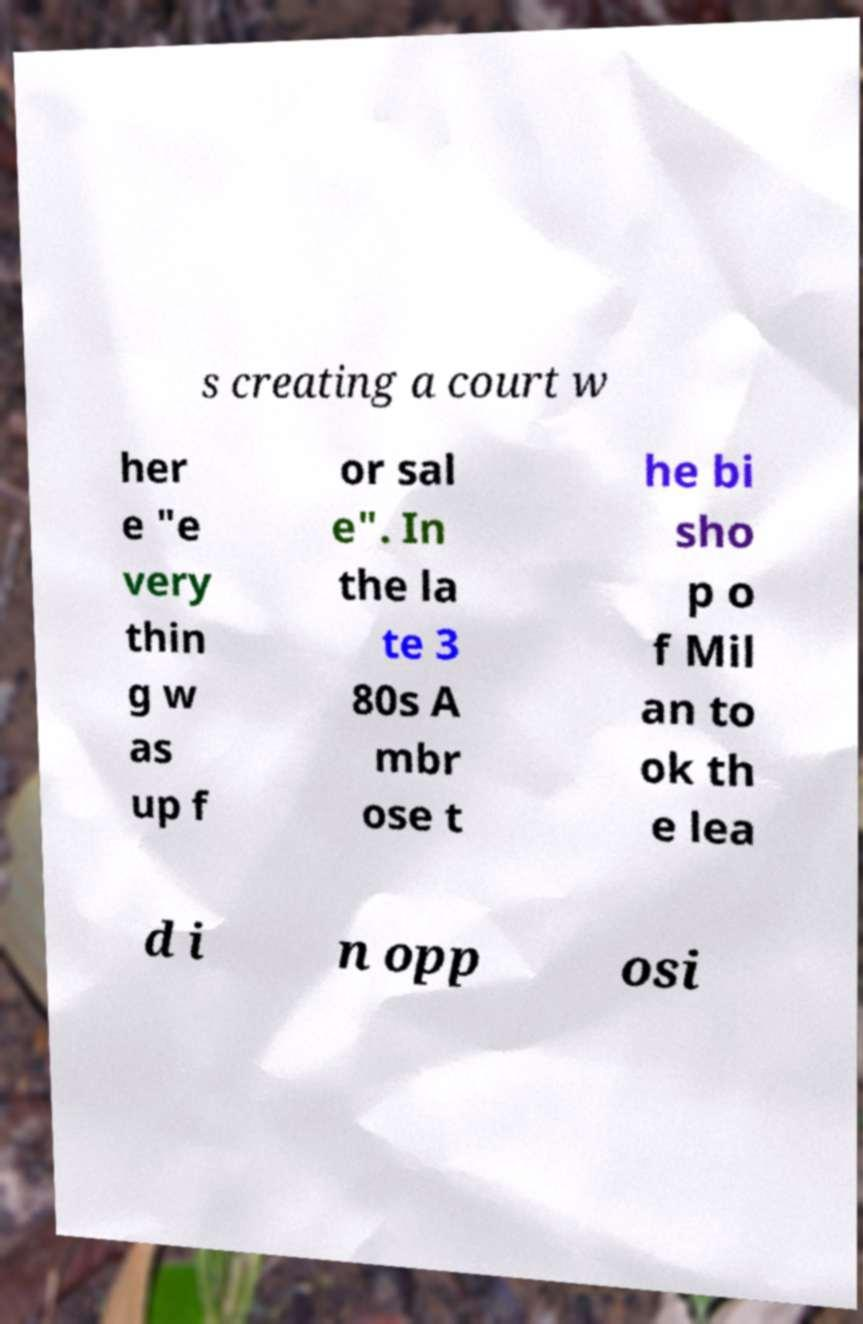Can you read and provide the text displayed in the image?This photo seems to have some interesting text. Can you extract and type it out for me? s creating a court w her e "e very thin g w as up f or sal e". In the la te 3 80s A mbr ose t he bi sho p o f Mil an to ok th e lea d i n opp osi 